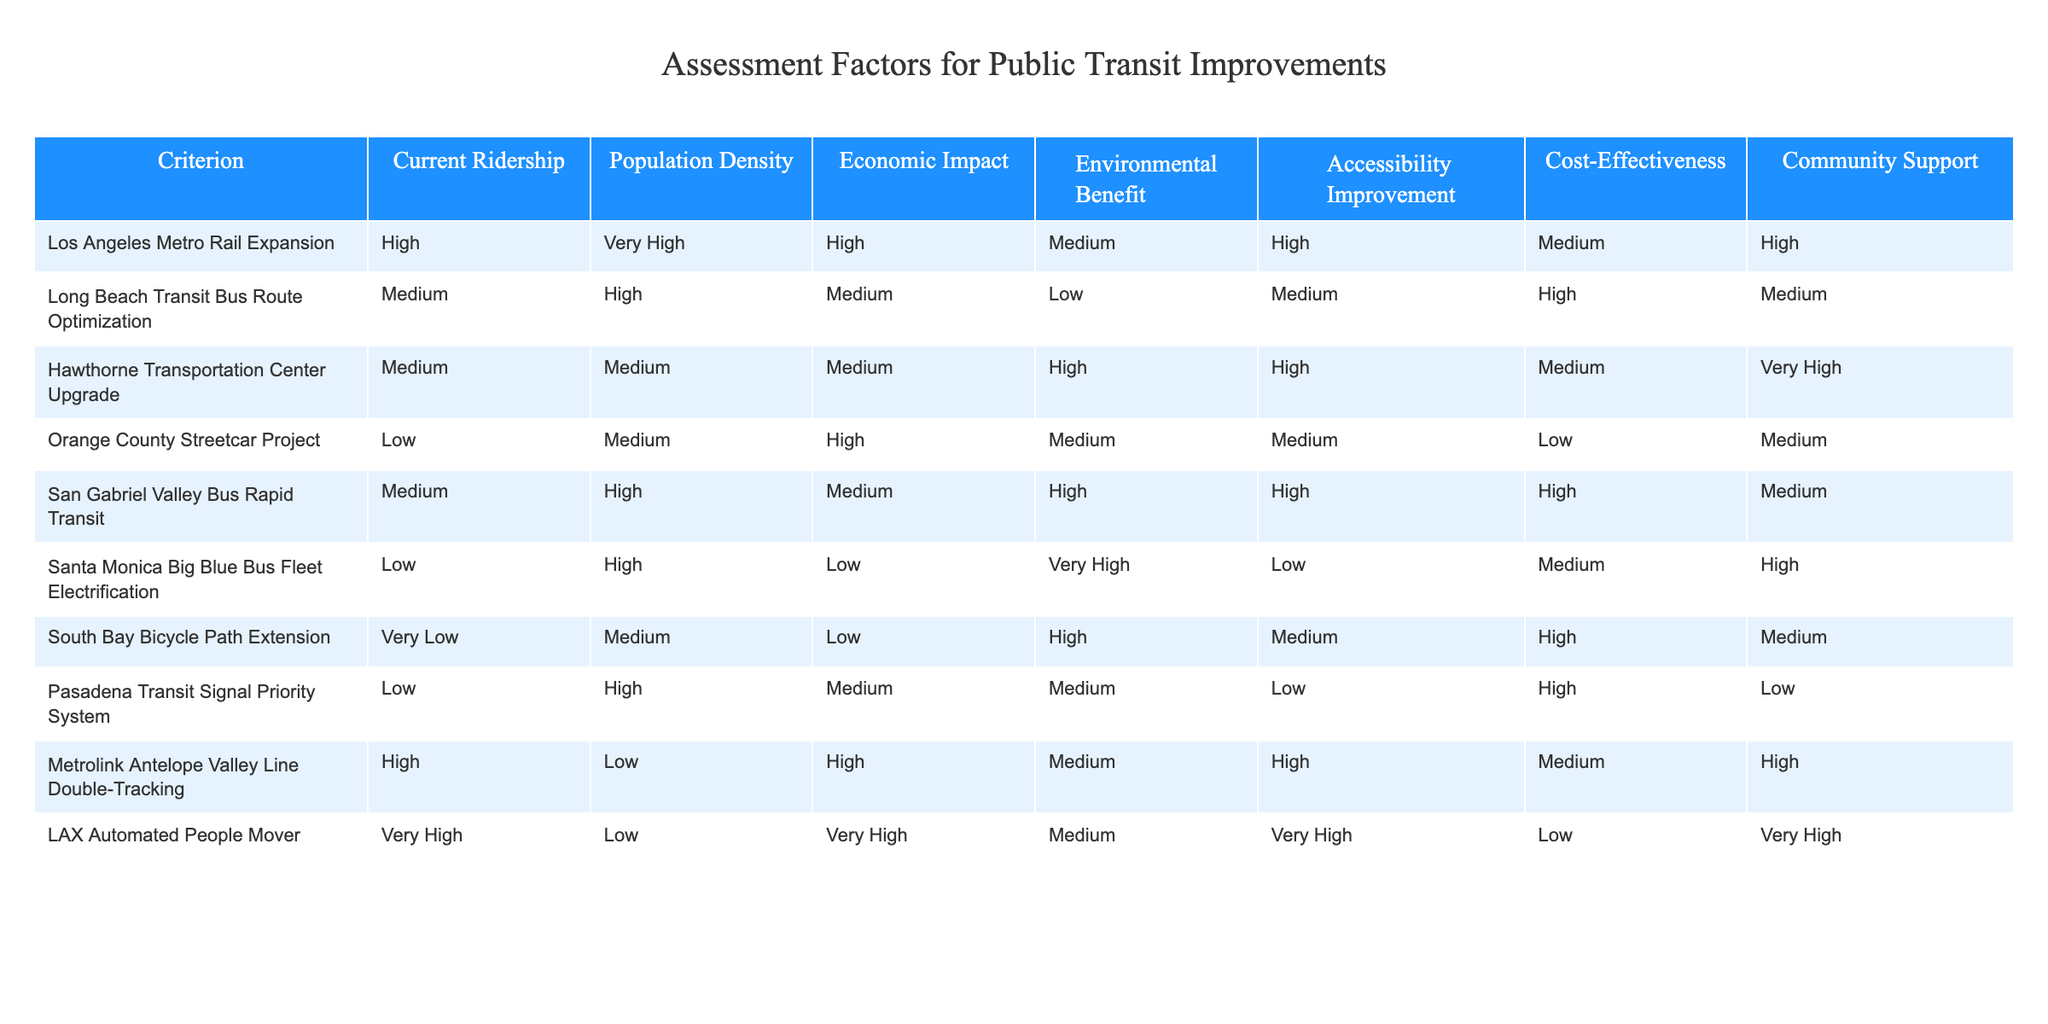What is the economic impact of the Hawthorne Transportation Center Upgrade? The table indicates that the economic impact for the Hawthorne Transportation Center Upgrade is categorized as Medium. This can be directly read from the relevant cell in the table corresponding to that project.
Answer: Medium Which project has the highest community support? According to the table, the Hawthorne Transportation Center Upgrade project has the highest community support, indicated as Very High. It stands at the top when comparing the values across all projects in that particular column.
Answer: Very High Is the Long Beach Transit Bus Route Optimization cost-effective? Looking at the table, the Long Beach Transit Bus Route Optimization is classified as High in terms of cost-effectiveness. Thus, it indicates that the project is considered cost-effective.
Answer: Yes What is the average current ridership among the projects? To find the average current ridership, we categorize the ridership levels as follows: High = 1, Medium = 0.5, Low = 0, Very Low = 0. This gives us values for the projects as follows: Los Angeles Metro Rail Expansion = 1, Long Beach Transit = 0.5, Hawthorne = 0.5, and others as needed. Adding these values (1 + 0.5 + 0.5 + 0 + 0 + 0 + 0 + 0 + 1) and dividing by the number of projects (9), we get an average of 0.33 which indicates a medium level of ridership.
Answer: 0.33 Which project has the lowest environmental benefit? By looking through the Environmental Benefit column in the table, the Santa Monica Big Blue Bus Fleet Electrification project has a Low designation, which is lower than any other project listed.
Answer: Santa Monica Big Blue Bus Fleet Electrification What is the unique combination of features for the LAX Automated People Mover compared to the other projects? The LAX Automated People Mover has Very High ratings in Current Ridership and Economic Impact, Very High in Accessibility Improvement, and Low in Cost-Effectiveness. This combination makes it unique as it excels in ridership and economic impact while ranking low in terms of cost-effectiveness compared to others.
Answer: Very High in ridership and economic impact, Low in cost-effectiveness 